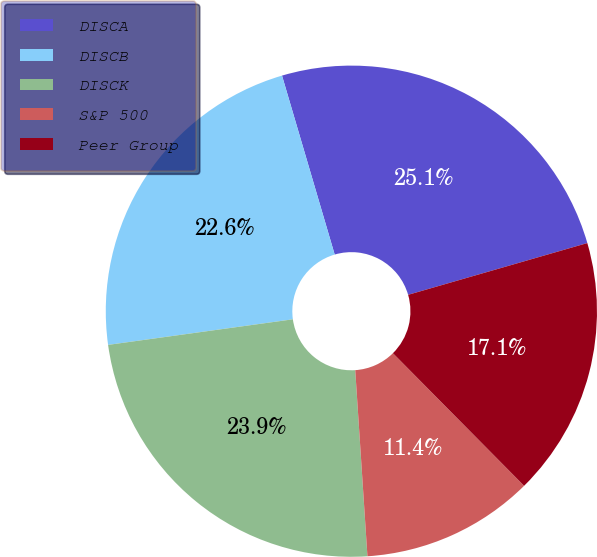Convert chart to OTSL. <chart><loc_0><loc_0><loc_500><loc_500><pie_chart><fcel>DISCA<fcel>DISCB<fcel>DISCK<fcel>S&P 500<fcel>Peer Group<nl><fcel>25.08%<fcel>22.63%<fcel>23.85%<fcel>11.37%<fcel>17.06%<nl></chart> 